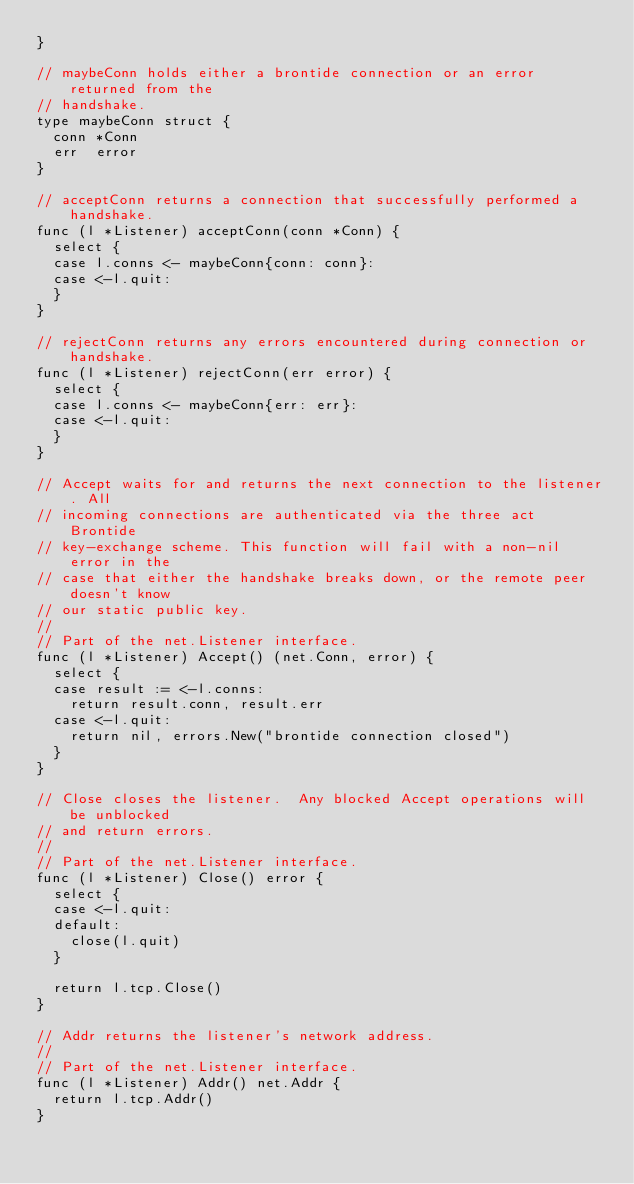<code> <loc_0><loc_0><loc_500><loc_500><_Go_>}

// maybeConn holds either a brontide connection or an error returned from the
// handshake.
type maybeConn struct {
	conn *Conn
	err  error
}

// acceptConn returns a connection that successfully performed a handshake.
func (l *Listener) acceptConn(conn *Conn) {
	select {
	case l.conns <- maybeConn{conn: conn}:
	case <-l.quit:
	}
}

// rejectConn returns any errors encountered during connection or handshake.
func (l *Listener) rejectConn(err error) {
	select {
	case l.conns <- maybeConn{err: err}:
	case <-l.quit:
	}
}

// Accept waits for and returns the next connection to the listener. All
// incoming connections are authenticated via the three act Brontide
// key-exchange scheme. This function will fail with a non-nil error in the
// case that either the handshake breaks down, or the remote peer doesn't know
// our static public key.
//
// Part of the net.Listener interface.
func (l *Listener) Accept() (net.Conn, error) {
	select {
	case result := <-l.conns:
		return result.conn, result.err
	case <-l.quit:
		return nil, errors.New("brontide connection closed")
	}
}

// Close closes the listener.  Any blocked Accept operations will be unblocked
// and return errors.
//
// Part of the net.Listener interface.
func (l *Listener) Close() error {
	select {
	case <-l.quit:
	default:
		close(l.quit)
	}

	return l.tcp.Close()
}

// Addr returns the listener's network address.
//
// Part of the net.Listener interface.
func (l *Listener) Addr() net.Addr {
	return l.tcp.Addr()
}
</code> 